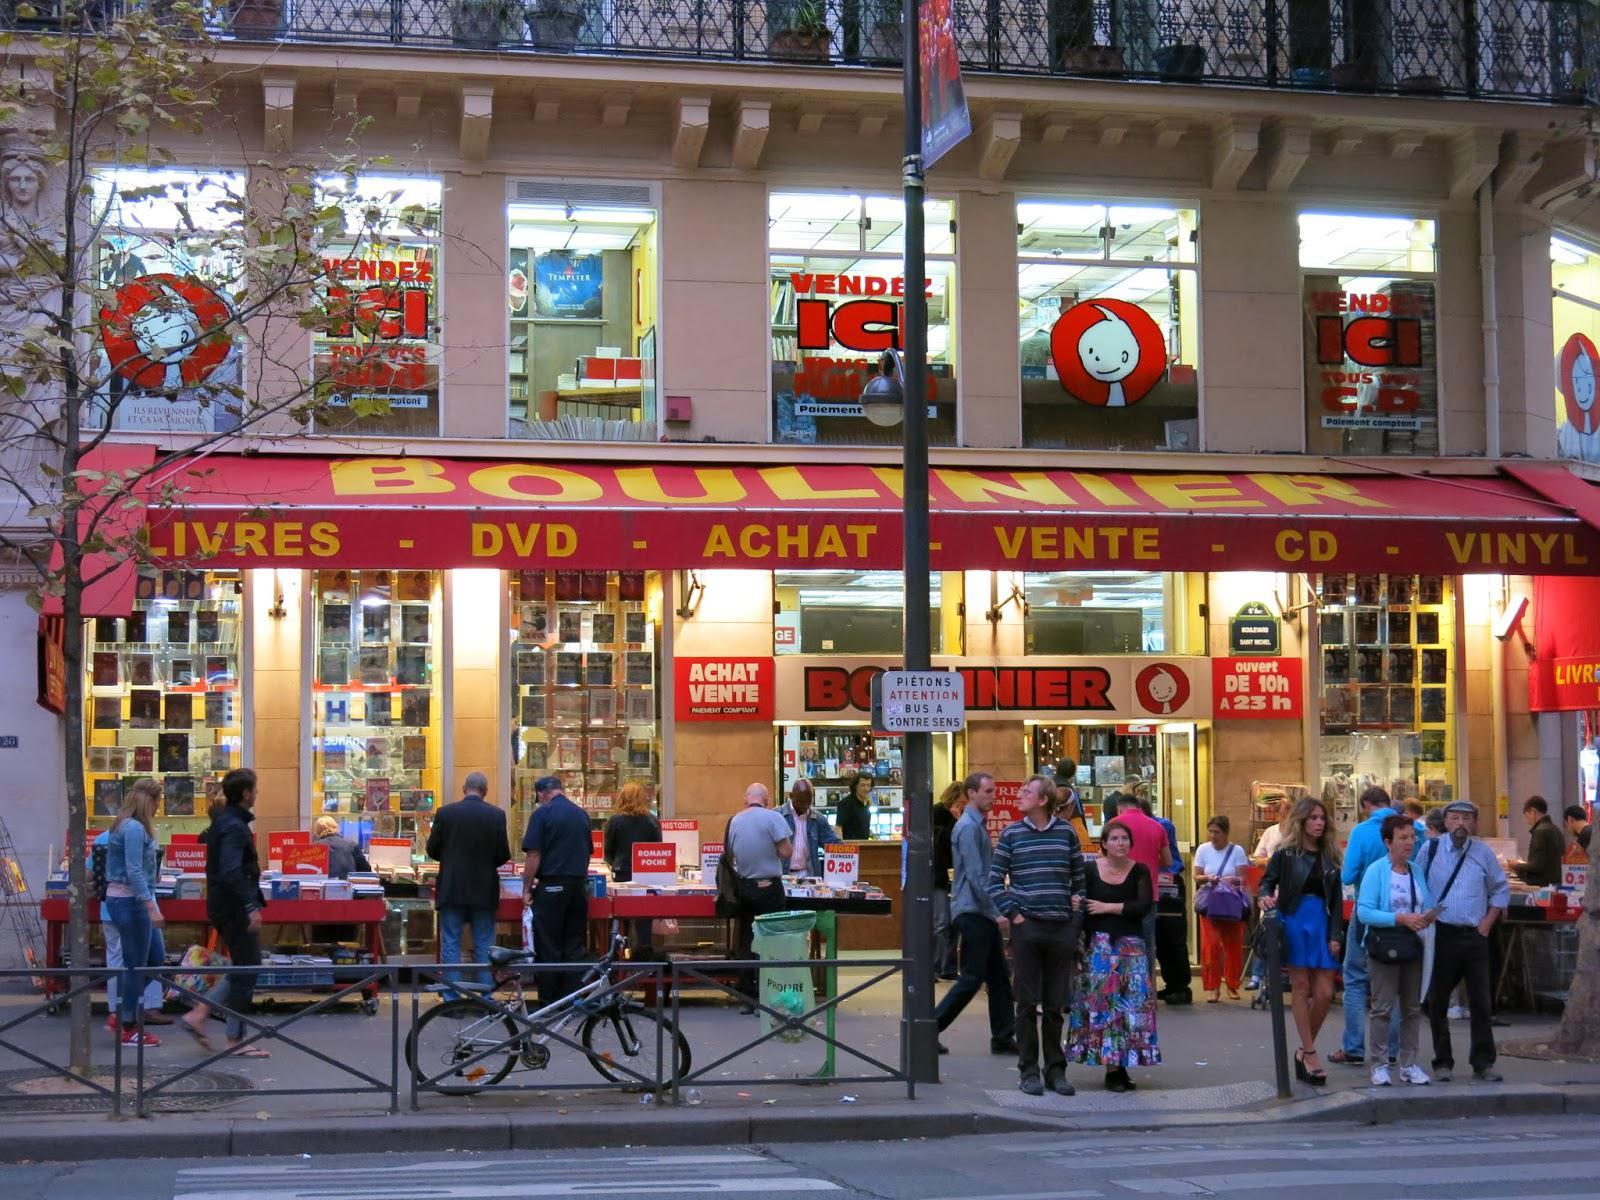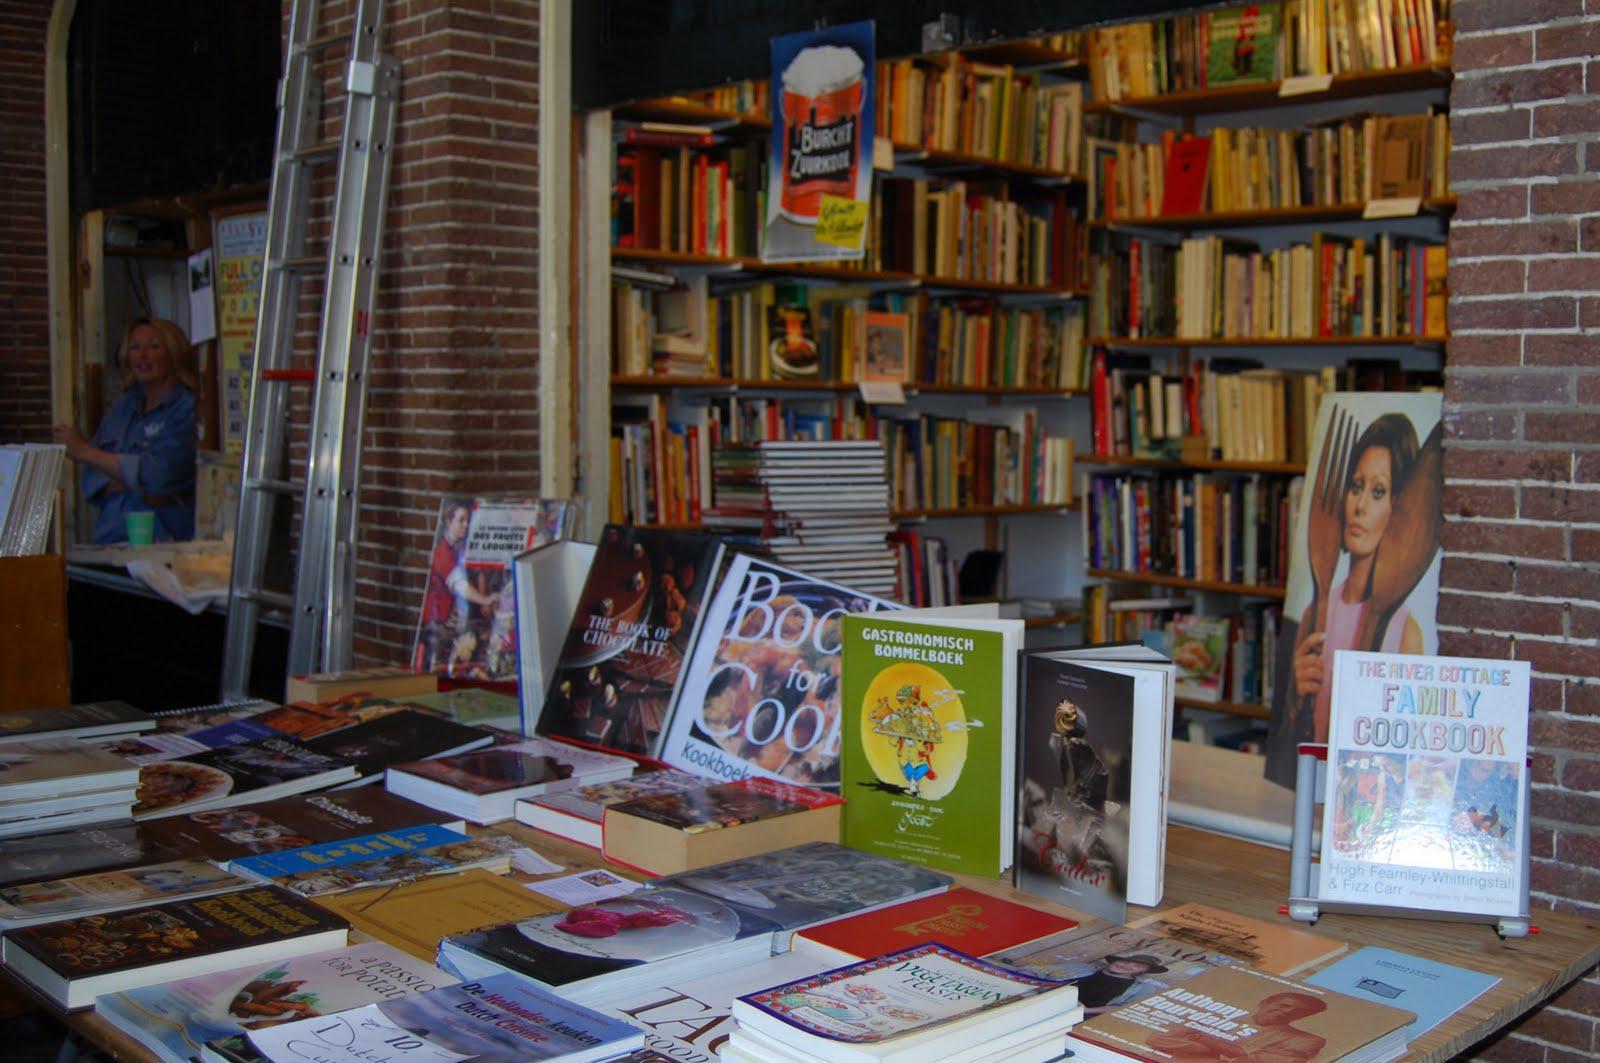The first image is the image on the left, the second image is the image on the right. Examine the images to the left and right. Is the description "An image shows multiple people milling around near a store entrance that features red signage." accurate? Answer yes or no. Yes. The first image is the image on the left, the second image is the image on the right. For the images displayed, is the sentence "There are more than half a dozen people standing around in the image on the left." factually correct? Answer yes or no. Yes. 